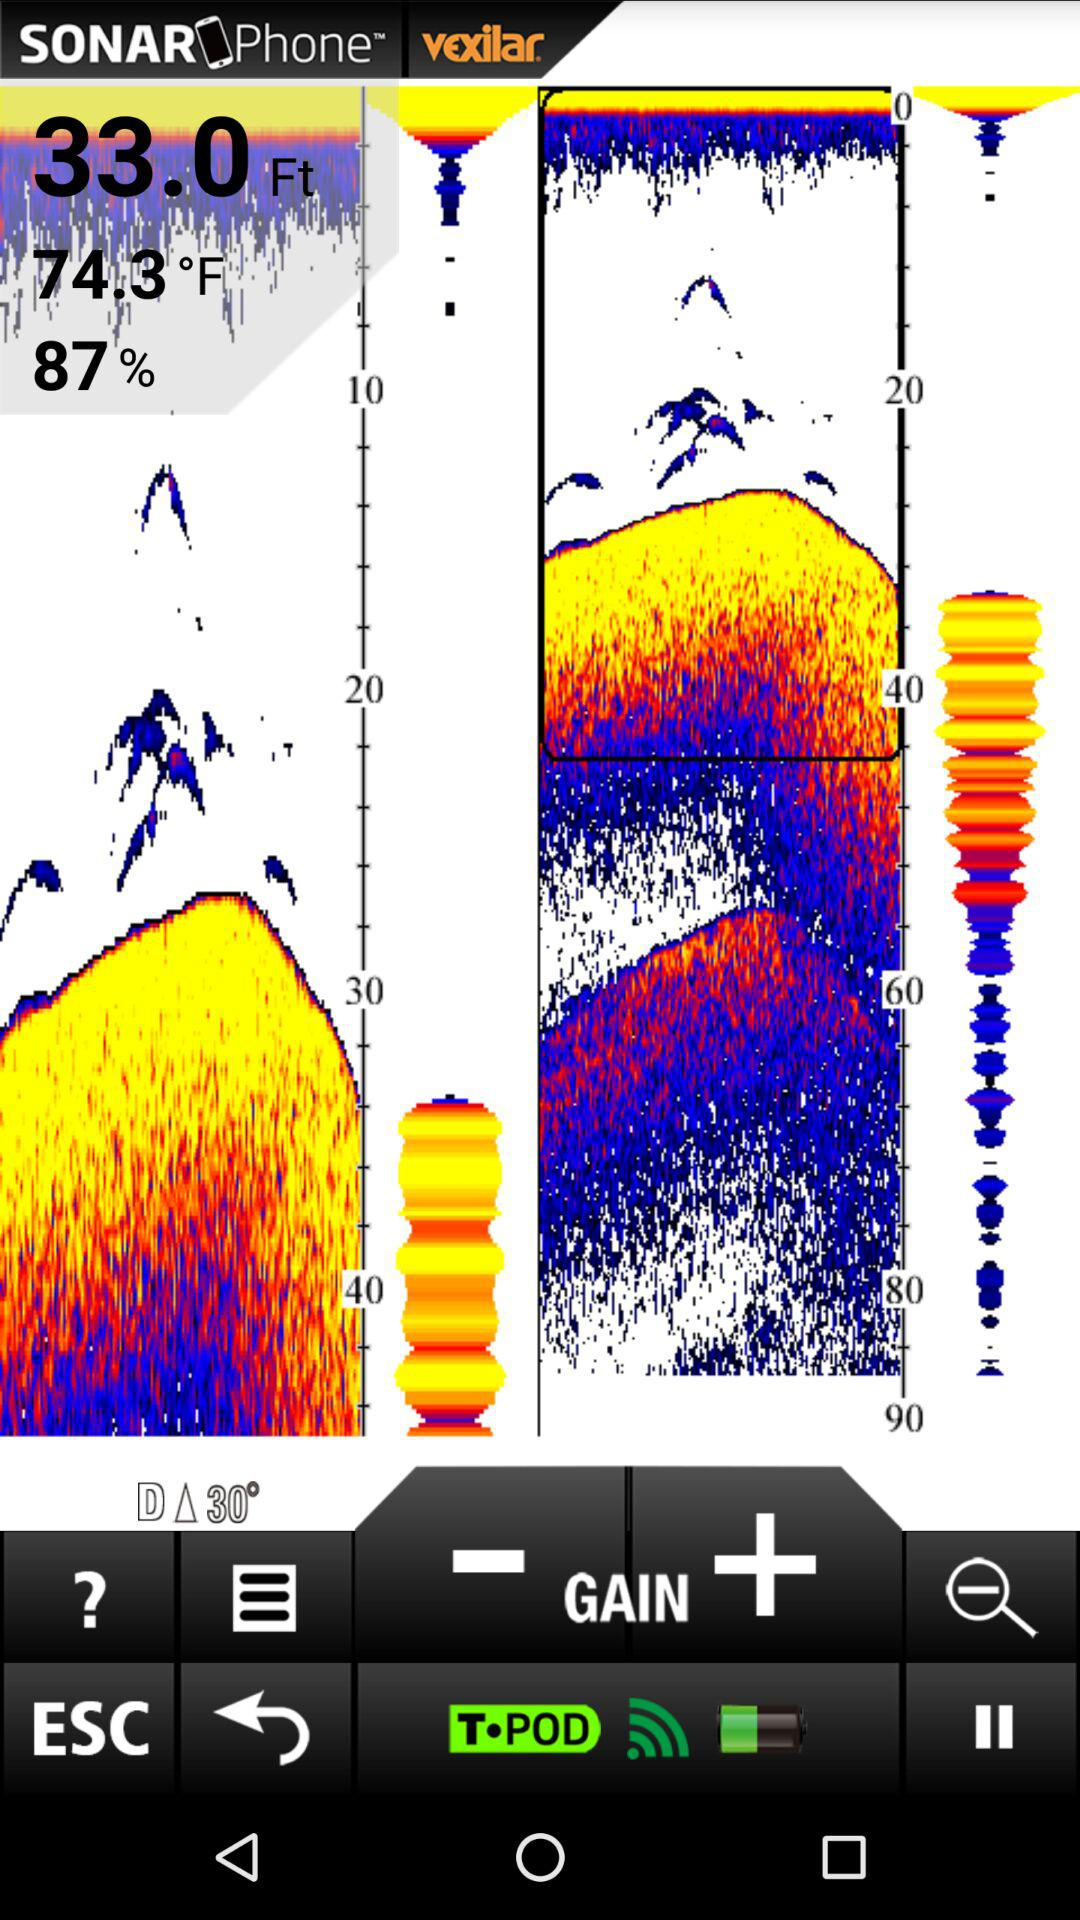How many feet are displayed on the screen? There are 33 feet displayed on the screen. 